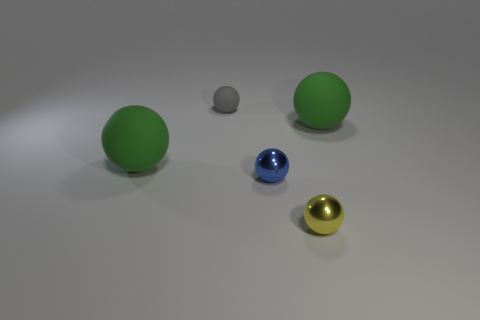How big is the blue shiny object in front of the large object on the right side of the small blue ball?
Your response must be concise. Small. Are there more cyan blocks than small yellow things?
Your answer should be very brief. No. Do the gray matte object to the left of the blue object and the small yellow object have the same size?
Keep it short and to the point. Yes. Does the small rubber thing have the same shape as the yellow metallic object?
Your response must be concise. Yes. What size is the blue thing that is the same shape as the gray object?
Offer a very short reply. Small. Is the number of gray objects behind the tiny rubber object greater than the number of small blue objects in front of the blue sphere?
Offer a very short reply. No. Does the small gray sphere have the same material as the large ball that is to the left of the tiny yellow ball?
Ensure brevity in your answer.  Yes. There is a sphere that is behind the blue metallic thing and to the right of the tiny gray object; what color is it?
Offer a terse response. Green. There is a tiny blue object behind the small yellow ball; what shape is it?
Your answer should be very brief. Sphere. There is a matte sphere left of the matte sphere that is behind the matte ball that is on the right side of the yellow metallic ball; what is its size?
Offer a terse response. Large. 